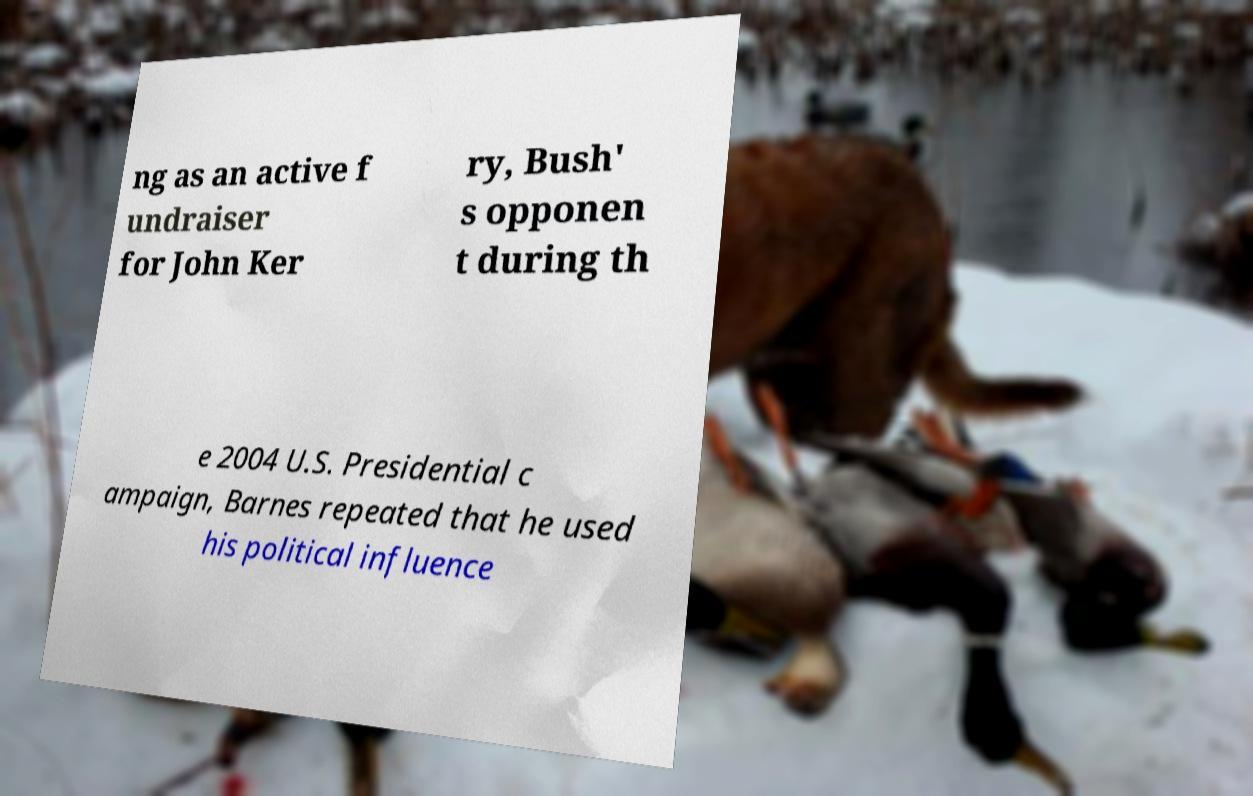For documentation purposes, I need the text within this image transcribed. Could you provide that? ng as an active f undraiser for John Ker ry, Bush' s opponen t during th e 2004 U.S. Presidential c ampaign, Barnes repeated that he used his political influence 